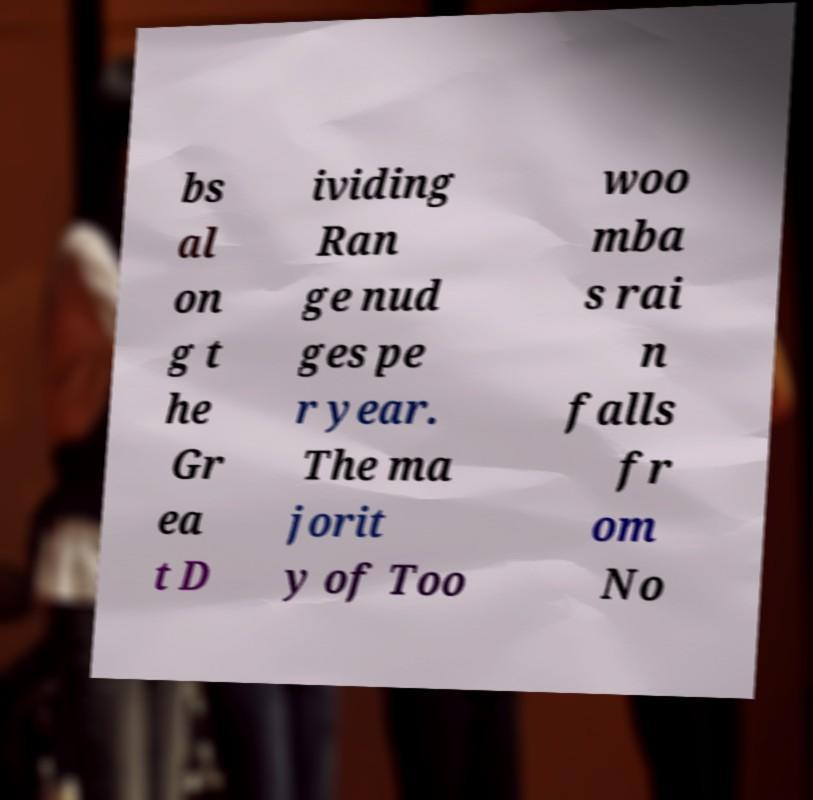There's text embedded in this image that I need extracted. Can you transcribe it verbatim? bs al on g t he Gr ea t D ividing Ran ge nud ges pe r year. The ma jorit y of Too woo mba s rai n falls fr om No 